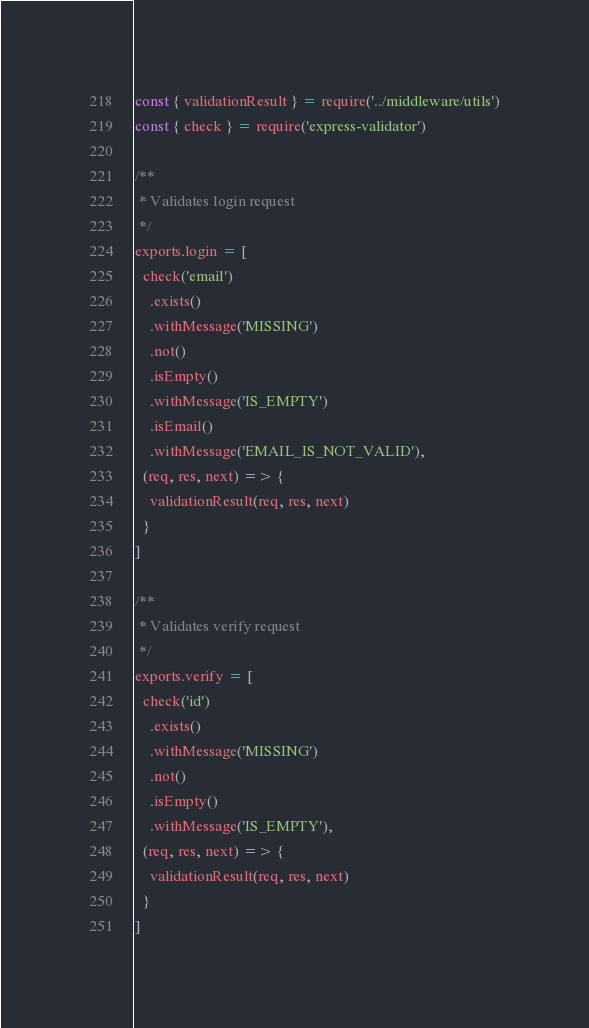Convert code to text. <code><loc_0><loc_0><loc_500><loc_500><_JavaScript_>const { validationResult } = require('../middleware/utils')
const { check } = require('express-validator')

/**
 * Validates login request
 */
exports.login = [
  check('email')
    .exists()
    .withMessage('MISSING')
    .not()
    .isEmpty()
    .withMessage('IS_EMPTY')
    .isEmail()
    .withMessage('EMAIL_IS_NOT_VALID'),
  (req, res, next) => {
    validationResult(req, res, next)
  }
]

/**
 * Validates verify request
 */
exports.verify = [
  check('id')
    .exists()
    .withMessage('MISSING')
    .not()
    .isEmpty()
    .withMessage('IS_EMPTY'),
  (req, res, next) => {
    validationResult(req, res, next)
  }
]
</code> 